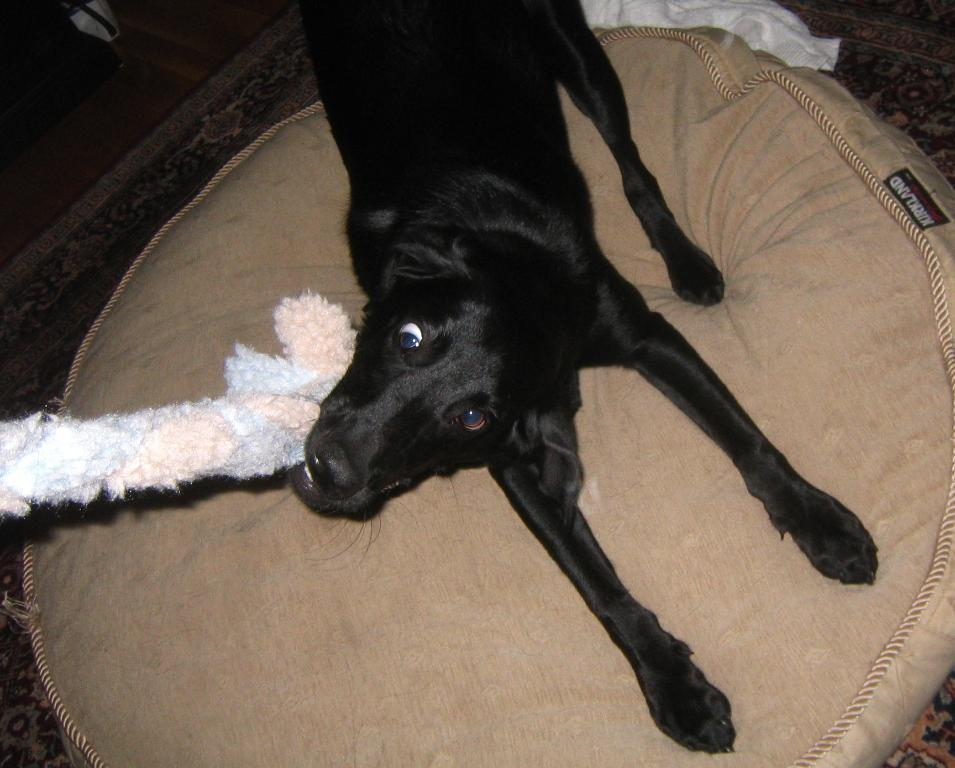What type of animal is present in the image? There is a dog in the image. What is the dog doing in the image? The dog is chewing an object. What piece of furniture can be seen in the image? There is a bed in the image. What other item is present in the image besides the dog and the bed? There is a cloth in the image. What type of flag is visible in the image? There is no flag present in the image. 